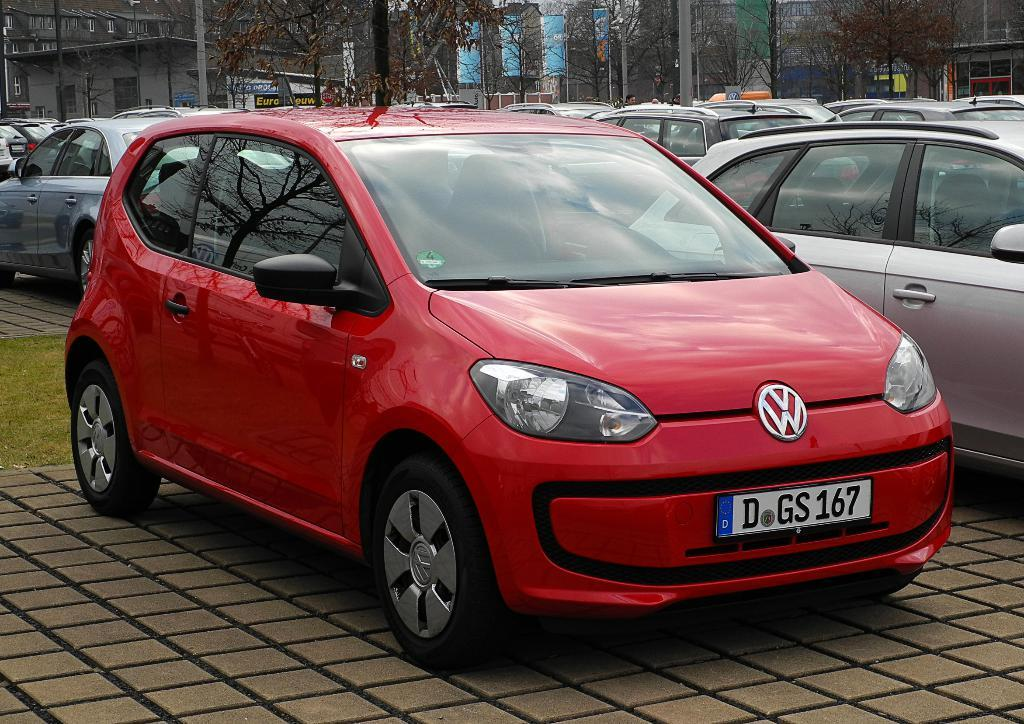What can be seen on the road in the image? There are vehicles on the road in the image. What is visible in the background of the image? There are trees, buildings, boards, poles, and banners in the background of the image. Can you describe the environment in the image? The image shows a road with vehicles, surrounded by trees, buildings, and various signage. What type of food is being served by the ghost in the image? There is no ghost or food present in the image. 